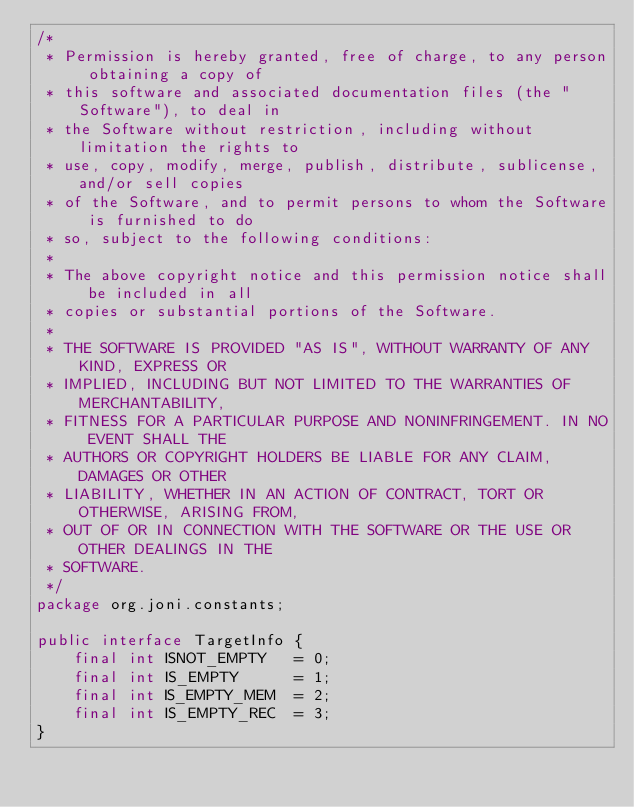<code> <loc_0><loc_0><loc_500><loc_500><_Java_>/*
 * Permission is hereby granted, free of charge, to any person obtaining a copy of
 * this software and associated documentation files (the "Software"), to deal in
 * the Software without restriction, including without limitation the rights to
 * use, copy, modify, merge, publish, distribute, sublicense, and/or sell copies
 * of the Software, and to permit persons to whom the Software is furnished to do
 * so, subject to the following conditions:
 *
 * The above copyright notice and this permission notice shall be included in all
 * copies or substantial portions of the Software.
 *
 * THE SOFTWARE IS PROVIDED "AS IS", WITHOUT WARRANTY OF ANY KIND, EXPRESS OR
 * IMPLIED, INCLUDING BUT NOT LIMITED TO THE WARRANTIES OF MERCHANTABILITY,
 * FITNESS FOR A PARTICULAR PURPOSE AND NONINFRINGEMENT. IN NO EVENT SHALL THE
 * AUTHORS OR COPYRIGHT HOLDERS BE LIABLE FOR ANY CLAIM, DAMAGES OR OTHER
 * LIABILITY, WHETHER IN AN ACTION OF CONTRACT, TORT OR OTHERWISE, ARISING FROM,
 * OUT OF OR IN CONNECTION WITH THE SOFTWARE OR THE USE OR OTHER DEALINGS IN THE
 * SOFTWARE.
 */
package org.joni.constants;

public interface TargetInfo {
    final int ISNOT_EMPTY   = 0;
    final int IS_EMPTY      = 1;
    final int IS_EMPTY_MEM  = 2;
    final int IS_EMPTY_REC  = 3;
}
</code> 